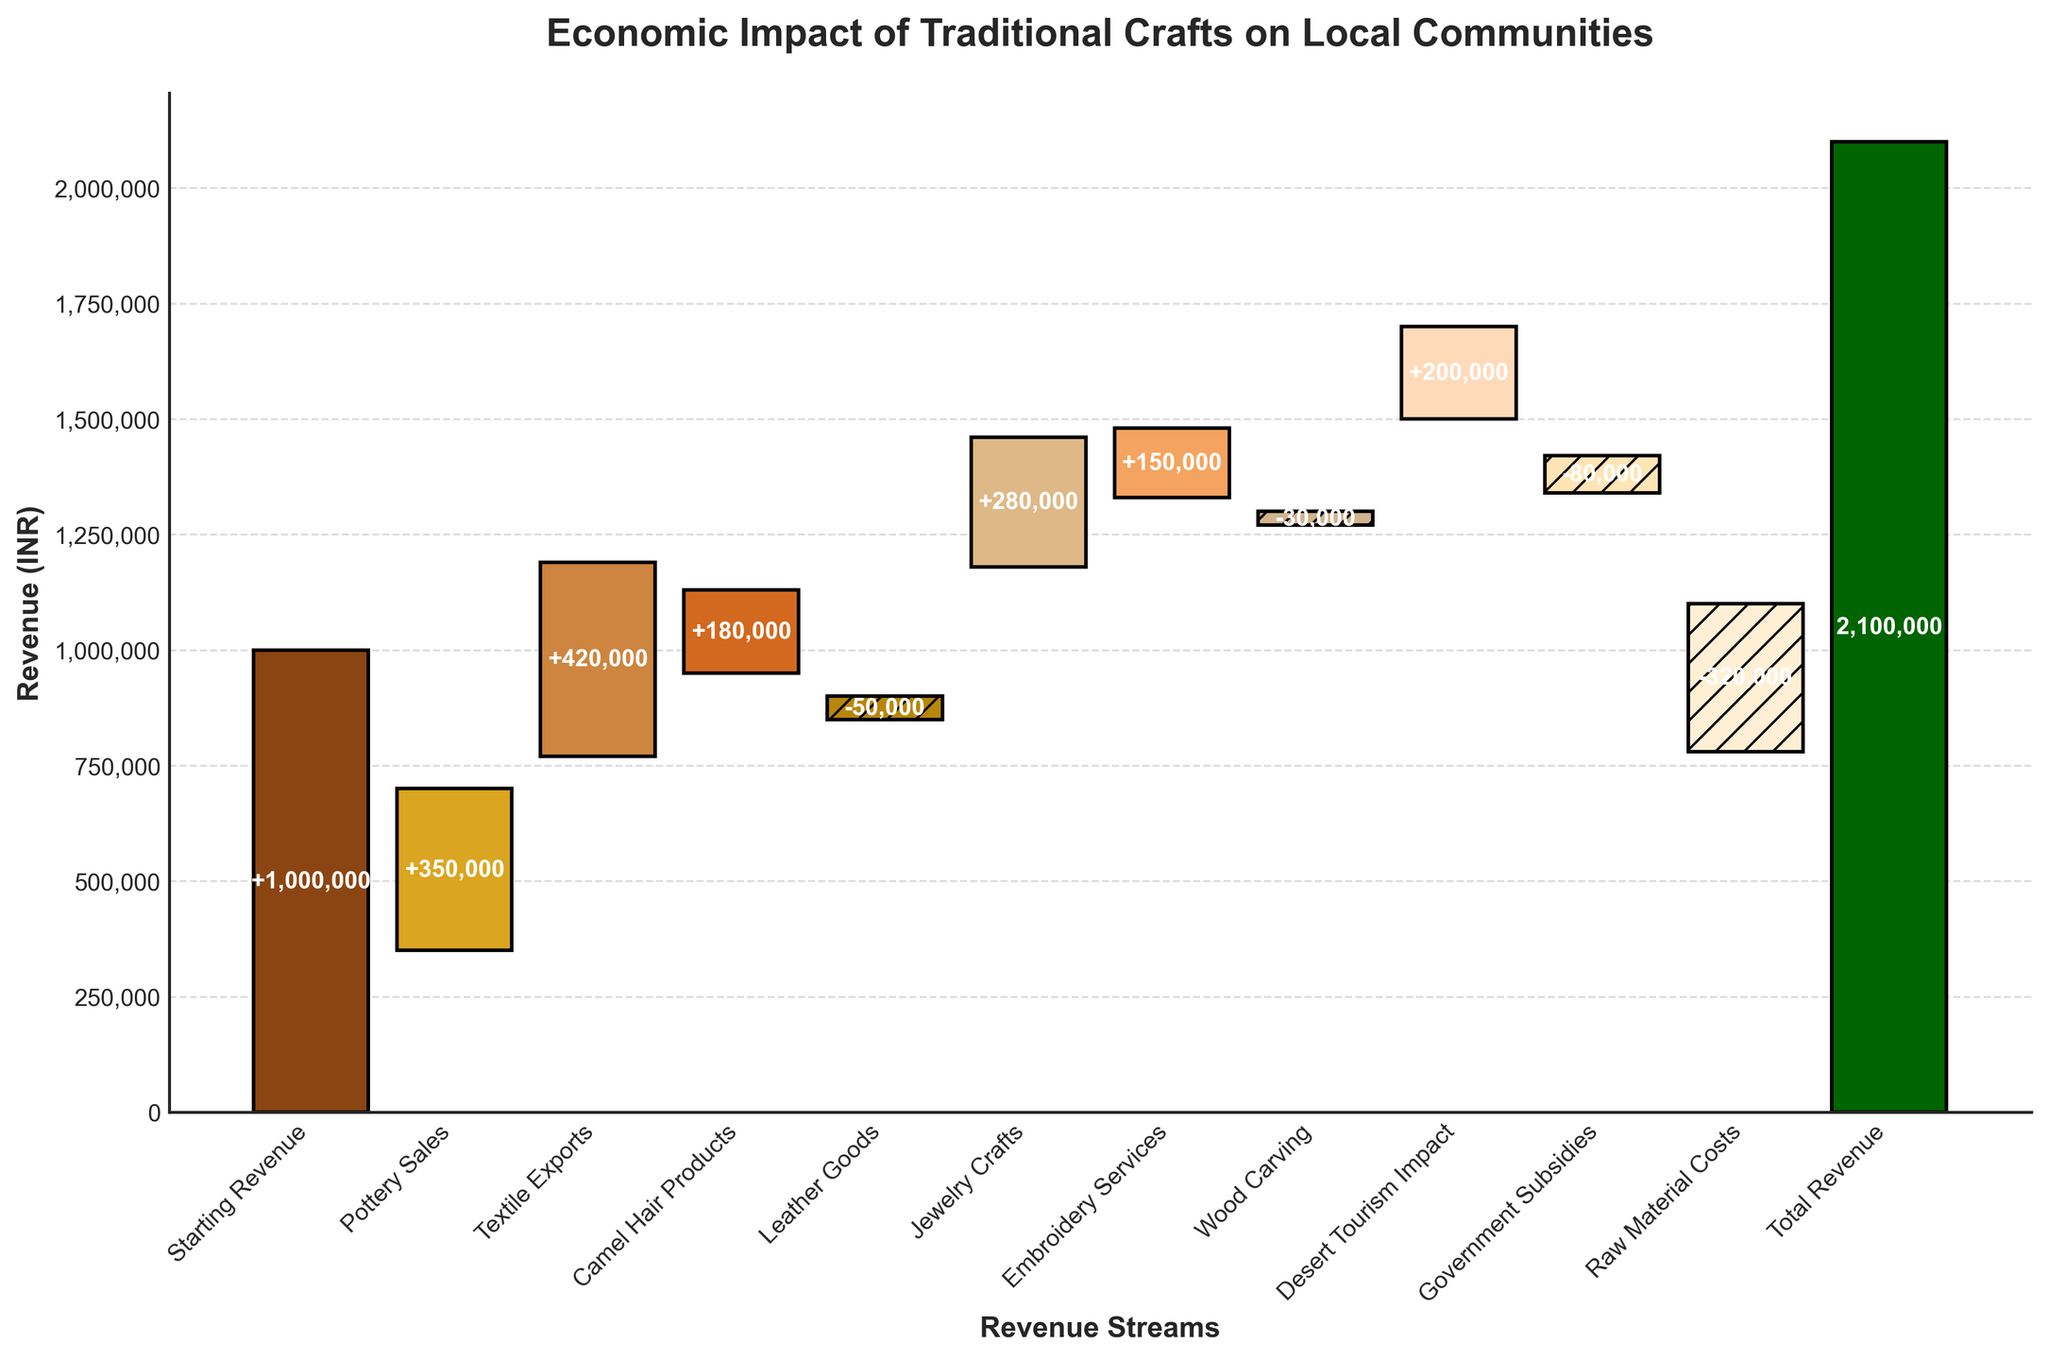What's the title of the chart? The title of the chart is found at the top and usually gives a clear idea of what the chart is about. In this case, you can read it directly from the top of the figure.
Answer: Economic Impact of Traditional Crafts on Local Communities What is the starting revenue? The starting revenue is listed at the top of the waterfall chart and is the point from which all other changes (both positive and negative) are measured. In this figure, it is clearly labeled at the beginning of the chart.
Answer: 1,000,000 INR How much revenue was added by Textile Exports and Jewelry Crafts combined? Add the revenue from Textile Exports and Jewelry Crafts together. From the chart, Textile Exports contribute 420,000 INR and Jewelry Crafts contribute 280,000 INR. The sum is 420,000 + 280,000 = 700,000 INR.
Answer: 700,000 INR Which revenue stream resulted in the largest negative impact? Look at the revenue streams that have negative values; these are easily recognizable by their downward bars and different styling. Compare these to find the largest. From the chart, Raw Material Costs have the largest negative impact with -320,000 INR.
Answer: Raw Material Costs By how much did Desert Tourism Impact increase the revenue? Desert Tourism Impact's contribution can be observed as a positive bar in the figure, labeled clearly. According to the chart, Desert Tourism Impact added 200,000 INR to the revenue.
Answer: 200,000 INR How much revenue is lost due to Government Subsidies and Raw Material Costs combined? Add the revenue losses from Government Subsidies and Raw Material Costs together. From the chart, Government Subsidies contribute -80,000 INR and Raw Material Costs contribute -320,000 INR. The sum is -80,000 + (-320,000) = -400,000 INR.
Answer: -400,000 INR Which category contributed the most to the revenue after considering all positive and negative contributions? Look at the cumulative effect of all individual categories (both positive and negative). According to the chart, the total revenue at the end of the chart is the cumulative result, which is 2,100,000 INR. The category contributing the most to this is Pottery Sales followed by Textile Exports.
Answer: Pottery Sales What is the net revenue after considering all the values? The net revenue is the last value shown at the end of the waterfall chart, which represents the sum of the starting revenue and all subsequent changes. As shown in the chart, the final value is 2,100,000 INR.
Answer: 2,100,000 INR How does the impact of Leather Goods compare to Wood Carving? Compare the values of Leather Goods and Wood Carving. Leather Goods result in -50,000 INR and Wood Carving results in -30,000 INR. Leather Goods have a more significant negative impact compared to Wood Carving.
Answer: Leather Goods have a larger negative impact than Wood Carving 